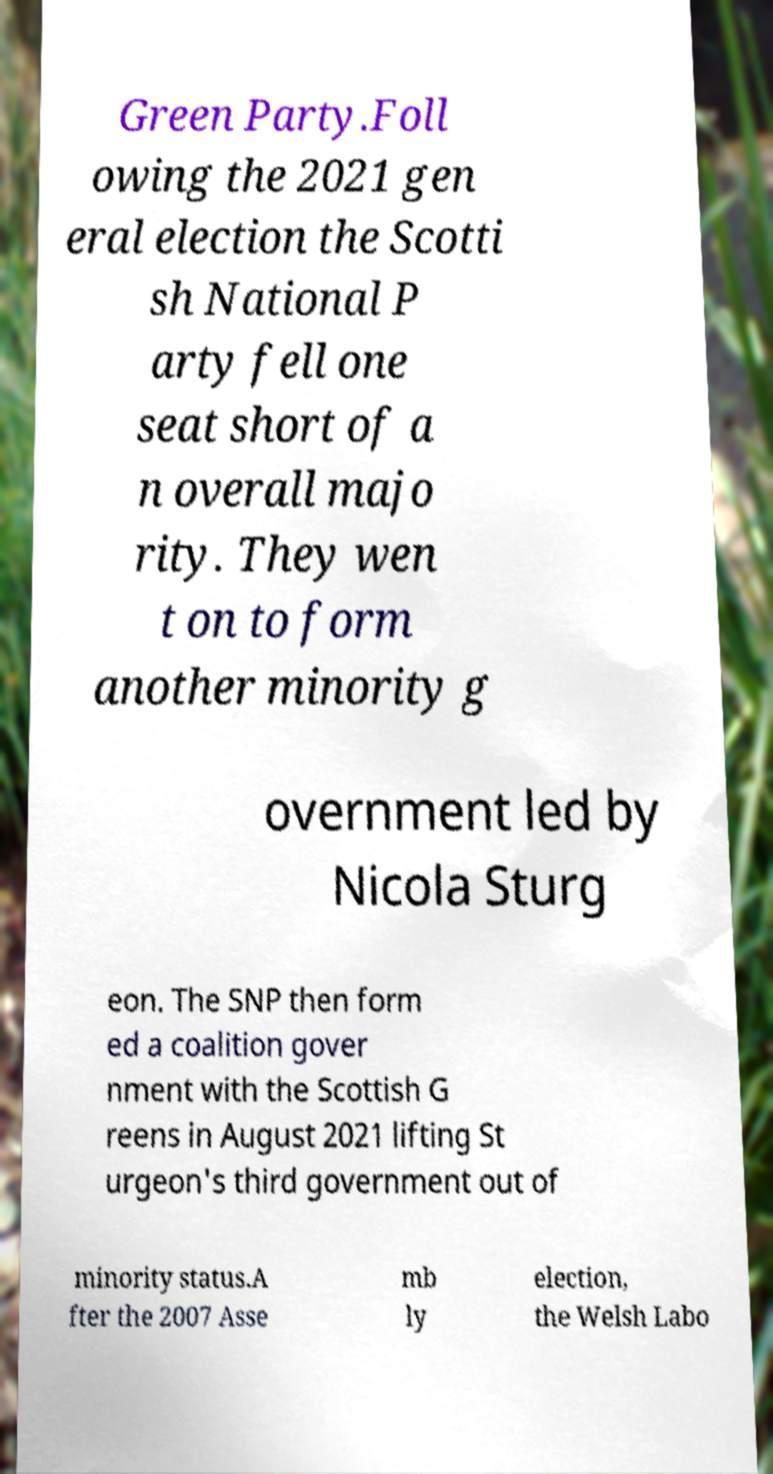Can you accurately transcribe the text from the provided image for me? Green Party.Foll owing the 2021 gen eral election the Scotti sh National P arty fell one seat short of a n overall majo rity. They wen t on to form another minority g overnment led by Nicola Sturg eon. The SNP then form ed a coalition gover nment with the Scottish G reens in August 2021 lifting St urgeon's third government out of minority status.A fter the 2007 Asse mb ly election, the Welsh Labo 